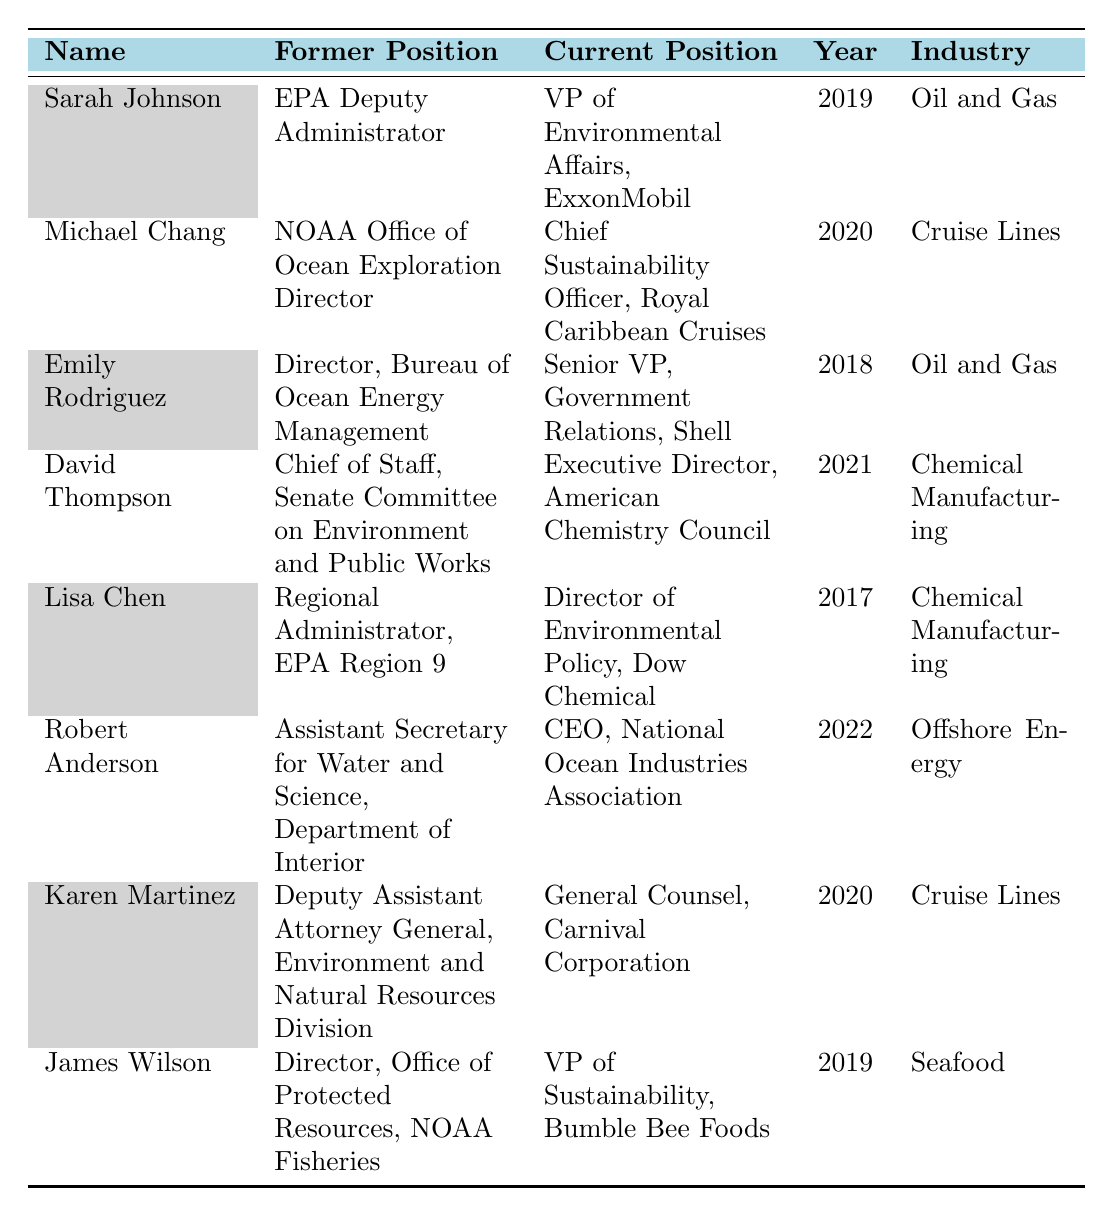What is the current position of Sarah Johnson? The table lists Sarah Johnson's current position in the fifth column, which states that she is the VP of Environmental Affairs at ExxonMobil.
Answer: VP of Environmental Affairs, ExxonMobil In what year did Emily Rodriguez transition to Shell? The year of transition for Emily Rodriguez is provided in the fourth column, which shows 2018.
Answer: 2018 How many individuals have transitioned from the EPA? Two individuals, Sarah Johnson and Lisa Chen, have former positions listed with the EPA in the second column, indicating their transitions from that agency.
Answer: 2 What industry does Michael Chang currently work in? The table shows that Michael Chang's current position is with Royal Caribbean Cruises, which is categorized under the Cruise Lines industry in the last column.
Answer: Cruise Lines Did any of the individuals transition to the cruise line industry? By reviewing the table, both Michael Chang and Karen Martinez are identified as transitioning to roles in the cruise line industry. Thus, the answer is yes.
Answer: Yes Which individual transitioned to a position in Seafood? The entry for James Wilson lists his current position as VP of Sustainability at Bumble Bee Foods, which is in the Seafood industry.
Answer: James Wilson What is the average year of transition for the individuals listed in the table? The years of transition are 2019, 2020, 2018, 2021, 2017, 2022, 2020, and 2019. Summing these gives 2016.875, and dividing by 8 provides an average year of transition of 2019.
Answer: 2019 What former position did David Thompson hold? David Thompson's former position is stated as Chief of Staff for the Senate Committee on Environment and Public Works in the second column of the table.
Answer: Chief of Staff, Senate Committee on Environment and Public Works Which two individuals worked in the chemical manufacturing industry? By examining the industry column, both David Thompson and Lisa Chen are identified as working in Chemical Manufacturing in the last column.
Answer: David Thompson and Lisa Chen What was the most recent transition documented in the table? The most recent transition year listed in the table is 2022, which corresponds to Robert Anderson, making it the latest transition documented.
Answer: Robert Anderson 